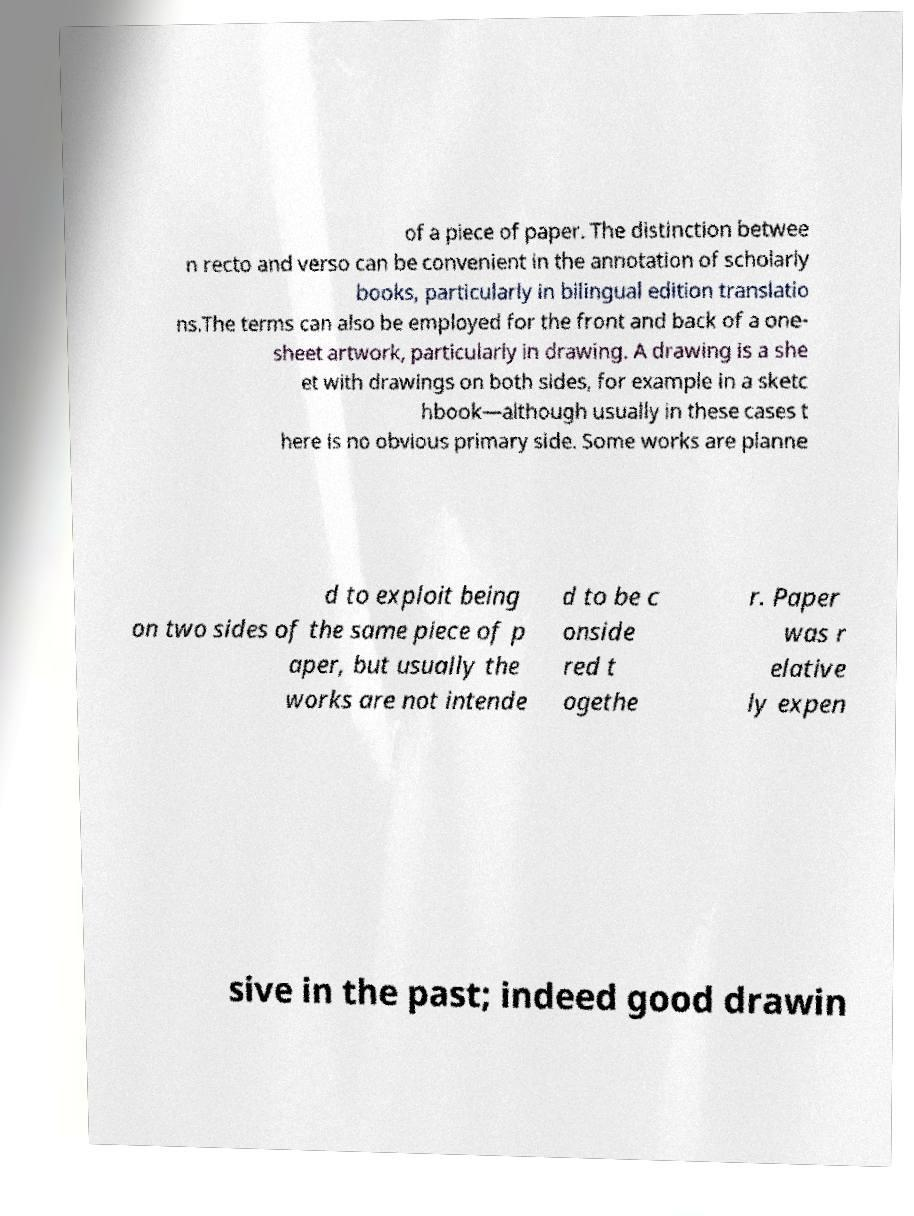Could you extract and type out the text from this image? of a piece of paper. The distinction betwee n recto and verso can be convenient in the annotation of scholarly books, particularly in bilingual edition translatio ns.The terms can also be employed for the front and back of a one- sheet artwork, particularly in drawing. A drawing is a she et with drawings on both sides, for example in a sketc hbook—although usually in these cases t here is no obvious primary side. Some works are planne d to exploit being on two sides of the same piece of p aper, but usually the works are not intende d to be c onside red t ogethe r. Paper was r elative ly expen sive in the past; indeed good drawin 